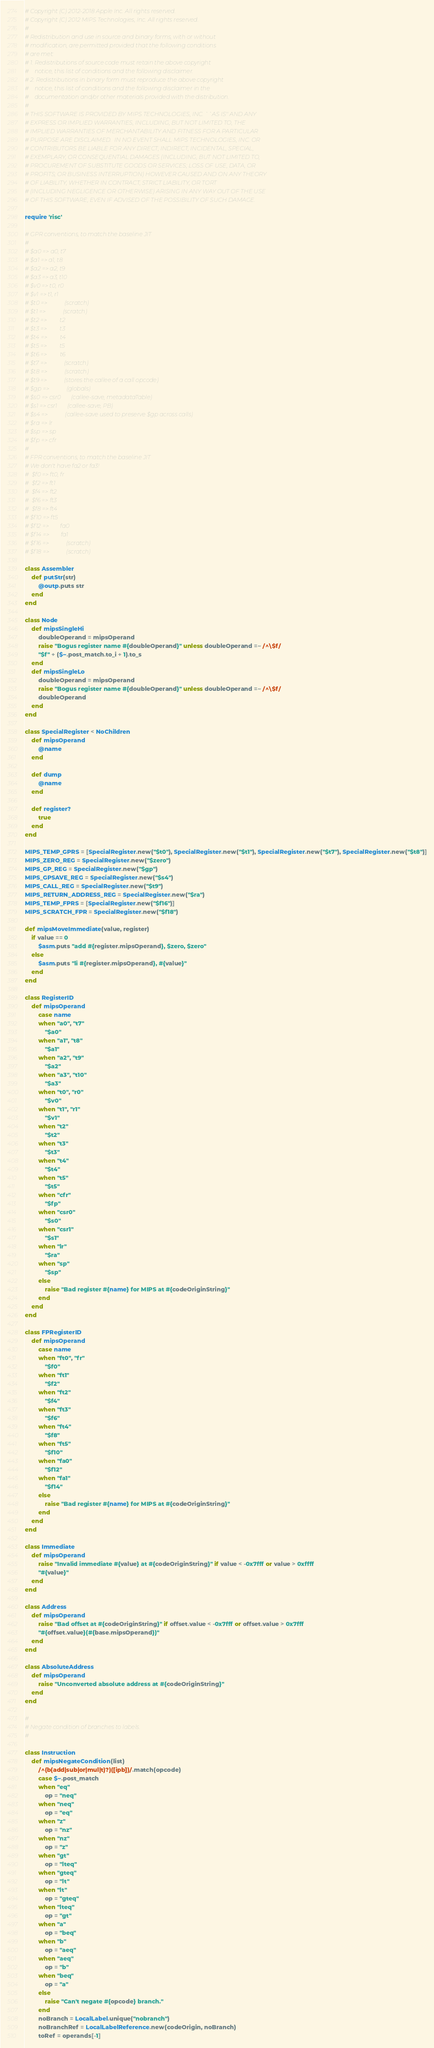Convert code to text. <code><loc_0><loc_0><loc_500><loc_500><_Ruby_># Copyright (C) 2012-2018 Apple Inc. All rights reserved.
# Copyright (C) 2012 MIPS Technologies, Inc. All rights reserved.
#
# Redistribution and use in source and binary forms, with or without
# modification, are permitted provided that the following conditions
# are met:
# 1. Redistributions of source code must retain the above copyright
#    notice, this list of conditions and the following disclaimer.
# 2. Redistributions in binary form must reproduce the above copyright
#    notice, this list of conditions and the following disclaimer in the
#    documentation and/or other materials provided with the distribution.
#
# THIS SOFTWARE IS PROVIDED BY MIPS TECHNOLOGIES, INC. ``AS IS'' AND ANY
# EXPRESS OR IMPLIED WARRANTIES, INCLUDING, BUT NOT LIMITED TO, THE
# IMPLIED WARRANTIES OF MERCHANTABILITY AND FITNESS FOR A PARTICULAR
# PURPOSE ARE DISCLAIMED.  IN NO EVENT SHALL MIPS TECHNOLOGIES, INC. OR
# CONTRIBUTORS BE LIABLE FOR ANY DIRECT, INDIRECT, INCIDENTAL, SPECIAL,
# EXEMPLARY, OR CONSEQUENTIAL DAMAGES (INCLUDING, BUT NOT LIMITED TO,
# PROCUREMENT OF SUBSTITUTE GOODS OR SERVICES; LOSS OF USE, DATA, OR
# PROFITS; OR BUSINESS INTERRUPTION) HOWEVER CAUSED AND ON ANY THEORY
# OF LIABILITY, WHETHER IN CONTRACT, STRICT LIABILITY, OR TORT
# (INCLUDING NEGLIGENCE OR OTHERWISE) ARISING IN ANY WAY OUT OF THE USE
# OF THIS SOFTWARE, EVEN IF ADVISED OF THE POSSIBILITY OF SUCH DAMAGE.

require 'risc'

# GPR conventions, to match the baseline JIT
#
# $a0 => a0, t7
# $a1 => a1, t8
# $a2 => a2, t9
# $a3 => a3, t10
# $v0 => t0, r0
# $v1 => t1, r1
# $t0 =>            (scratch)
# $t1 =>            (scratch)
# $t2 =>         t2
# $t3 =>         t3
# $t4 =>         t4
# $t5 =>         t5
# $t6 =>         t6
# $t7 =>            (scratch)
# $t8 =>            (scratch)
# $t9 =>            (stores the callee of a call opcode)
# $gp =>            (globals)
# $s0 => csr0       (callee-save, metadataTable)
# $s1 => csr1       (callee-save, PB)
# $s4 =>            (callee-save used to preserve $gp across calls)
# $ra => lr
# $sp => sp
# $fp => cfr
#
# FPR conventions, to match the baseline JIT
# We don't have fa2 or fa3!
#  $f0 => ft0, fr
#  $f2 => ft1
#  $f4 => ft2
#  $f6 => ft3
#  $f8 => ft4
# $f10 => ft5
# $f12 =>        fa0
# $f14 =>        fa1
# $f16 =>            (scratch)
# $f18 =>            (scratch)

class Assembler
    def putStr(str)
        @outp.puts str
    end
end

class Node
    def mipsSingleHi
        doubleOperand = mipsOperand
        raise "Bogus register name #{doubleOperand}" unless doubleOperand =~ /^\$f/
        "$f" + ($~.post_match.to_i + 1).to_s
    end
    def mipsSingleLo
        doubleOperand = mipsOperand
        raise "Bogus register name #{doubleOperand}" unless doubleOperand =~ /^\$f/
        doubleOperand
    end
end

class SpecialRegister < NoChildren
    def mipsOperand
        @name
    end

    def dump
        @name
    end

    def register?
        true
    end
end

MIPS_TEMP_GPRS = [SpecialRegister.new("$t0"), SpecialRegister.new("$t1"), SpecialRegister.new("$t7"), SpecialRegister.new("$t8")]
MIPS_ZERO_REG = SpecialRegister.new("$zero")
MIPS_GP_REG = SpecialRegister.new("$gp")
MIPS_GPSAVE_REG = SpecialRegister.new("$s4")
MIPS_CALL_REG = SpecialRegister.new("$t9")
MIPS_RETURN_ADDRESS_REG = SpecialRegister.new("$ra")
MIPS_TEMP_FPRS = [SpecialRegister.new("$f16")]
MIPS_SCRATCH_FPR = SpecialRegister.new("$f18")

def mipsMoveImmediate(value, register)
    if value == 0
        $asm.puts "add #{register.mipsOperand}, $zero, $zero"
    else
        $asm.puts "li #{register.mipsOperand}, #{value}"
    end
end

class RegisterID
    def mipsOperand
        case name
        when "a0", "t7"
            "$a0"
        when "a1", "t8"
            "$a1"
        when "a2", "t9"
            "$a2"
        when "a3", "t10"
            "$a3"
        when "t0", "r0"
            "$v0"
        when "t1", "r1"
            "$v1"
        when "t2"
            "$t2"
        when "t3"
            "$t3"
        when "t4"
            "$t4"
        when "t5"
            "$t5"
        when "cfr"
            "$fp"
        when "csr0"
            "$s0"
        when "csr1"
            "$s1"
        when "lr"
            "$ra"
        when "sp"
            "$sp"
        else
            raise "Bad register #{name} for MIPS at #{codeOriginString}"
        end
    end
end

class FPRegisterID
    def mipsOperand
        case name
        when "ft0", "fr"
            "$f0"
        when "ft1"
            "$f2"
        when "ft2"
            "$f4"
        when "ft3"
            "$f6"
        when "ft4"
            "$f8"
        when "ft5"
            "$f10"
        when "fa0"
            "$f12"
        when "fa1"
            "$f14"
        else
            raise "Bad register #{name} for MIPS at #{codeOriginString}"
        end
    end
end

class Immediate
    def mipsOperand
        raise "Invalid immediate #{value} at #{codeOriginString}" if value < -0x7fff or value > 0xffff
        "#{value}"
    end
end

class Address
    def mipsOperand
        raise "Bad offset at #{codeOriginString}" if offset.value < -0x7fff or offset.value > 0x7fff
        "#{offset.value}(#{base.mipsOperand})"
    end
end

class AbsoluteAddress
    def mipsOperand
        raise "Unconverted absolute address at #{codeOriginString}"
    end
end

#
# Negate condition of branches to labels.
#

class Instruction
    def mipsNegateCondition(list)
        /^(b(add|sub|or|mul|t)?)([ipb])/.match(opcode)
        case $~.post_match
        when "eq"
            op = "neq"
        when "neq"
            op = "eq"
        when "z"
            op = "nz"
        when "nz"
            op = "z"
        when "gt"
            op = "lteq"
        when "gteq"
            op = "lt"
        when "lt"
            op = "gteq"
        when "lteq"
            op = "gt"
        when "a"
            op = "beq"
        when "b"
            op = "aeq"
        when "aeq"
            op = "b"
        when "beq"
            op = "a"
        else
            raise "Can't negate #{opcode} branch."
        end
        noBranch = LocalLabel.unique("nobranch")
        noBranchRef = LocalLabelReference.new(codeOrigin, noBranch)
        toRef = operands[-1]</code> 